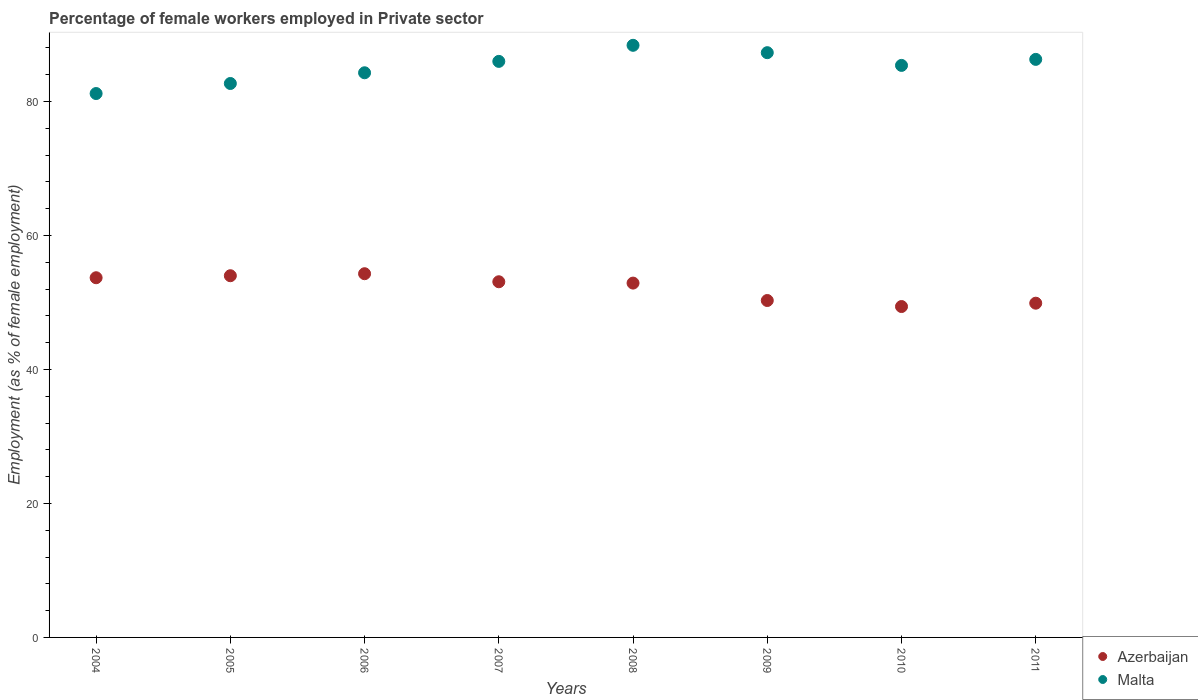How many different coloured dotlines are there?
Your answer should be compact. 2. Is the number of dotlines equal to the number of legend labels?
Give a very brief answer. Yes. What is the percentage of females employed in Private sector in Malta in 2010?
Your answer should be compact. 85.4. Across all years, what is the maximum percentage of females employed in Private sector in Malta?
Keep it short and to the point. 88.4. Across all years, what is the minimum percentage of females employed in Private sector in Malta?
Ensure brevity in your answer.  81.2. In which year was the percentage of females employed in Private sector in Azerbaijan minimum?
Your response must be concise. 2010. What is the total percentage of females employed in Private sector in Malta in the graph?
Make the answer very short. 681.6. What is the difference between the percentage of females employed in Private sector in Malta in 2005 and that in 2009?
Your answer should be very brief. -4.6. What is the difference between the percentage of females employed in Private sector in Malta in 2006 and the percentage of females employed in Private sector in Azerbaijan in 2011?
Your answer should be very brief. 34.4. What is the average percentage of females employed in Private sector in Malta per year?
Provide a succinct answer. 85.2. In the year 2008, what is the difference between the percentage of females employed in Private sector in Malta and percentage of females employed in Private sector in Azerbaijan?
Your response must be concise. 35.5. What is the ratio of the percentage of females employed in Private sector in Malta in 2009 to that in 2011?
Offer a terse response. 1.01. Is the percentage of females employed in Private sector in Malta in 2004 less than that in 2011?
Your response must be concise. Yes. Is the difference between the percentage of females employed in Private sector in Malta in 2004 and 2006 greater than the difference between the percentage of females employed in Private sector in Azerbaijan in 2004 and 2006?
Keep it short and to the point. No. What is the difference between the highest and the second highest percentage of females employed in Private sector in Malta?
Provide a short and direct response. 1.1. What is the difference between the highest and the lowest percentage of females employed in Private sector in Azerbaijan?
Make the answer very short. 4.9. In how many years, is the percentage of females employed in Private sector in Malta greater than the average percentage of females employed in Private sector in Malta taken over all years?
Provide a short and direct response. 5. Is the sum of the percentage of females employed in Private sector in Malta in 2007 and 2010 greater than the maximum percentage of females employed in Private sector in Azerbaijan across all years?
Ensure brevity in your answer.  Yes. Is the percentage of females employed in Private sector in Azerbaijan strictly greater than the percentage of females employed in Private sector in Malta over the years?
Keep it short and to the point. No. Is the percentage of females employed in Private sector in Azerbaijan strictly less than the percentage of females employed in Private sector in Malta over the years?
Provide a short and direct response. Yes. What is the difference between two consecutive major ticks on the Y-axis?
Provide a succinct answer. 20. Are the values on the major ticks of Y-axis written in scientific E-notation?
Offer a very short reply. No. Does the graph contain any zero values?
Offer a terse response. No. How many legend labels are there?
Offer a terse response. 2. What is the title of the graph?
Keep it short and to the point. Percentage of female workers employed in Private sector. Does "Somalia" appear as one of the legend labels in the graph?
Your answer should be very brief. No. What is the label or title of the X-axis?
Give a very brief answer. Years. What is the label or title of the Y-axis?
Offer a terse response. Employment (as % of female employment). What is the Employment (as % of female employment) in Azerbaijan in 2004?
Ensure brevity in your answer.  53.7. What is the Employment (as % of female employment) of Malta in 2004?
Offer a very short reply. 81.2. What is the Employment (as % of female employment) of Azerbaijan in 2005?
Ensure brevity in your answer.  54. What is the Employment (as % of female employment) in Malta in 2005?
Offer a very short reply. 82.7. What is the Employment (as % of female employment) of Azerbaijan in 2006?
Offer a very short reply. 54.3. What is the Employment (as % of female employment) in Malta in 2006?
Offer a terse response. 84.3. What is the Employment (as % of female employment) in Azerbaijan in 2007?
Offer a very short reply. 53.1. What is the Employment (as % of female employment) of Azerbaijan in 2008?
Ensure brevity in your answer.  52.9. What is the Employment (as % of female employment) in Malta in 2008?
Keep it short and to the point. 88.4. What is the Employment (as % of female employment) in Azerbaijan in 2009?
Provide a succinct answer. 50.3. What is the Employment (as % of female employment) in Malta in 2009?
Offer a very short reply. 87.3. What is the Employment (as % of female employment) of Azerbaijan in 2010?
Keep it short and to the point. 49.4. What is the Employment (as % of female employment) in Malta in 2010?
Offer a terse response. 85.4. What is the Employment (as % of female employment) in Azerbaijan in 2011?
Your response must be concise. 49.9. What is the Employment (as % of female employment) of Malta in 2011?
Offer a terse response. 86.3. Across all years, what is the maximum Employment (as % of female employment) of Azerbaijan?
Offer a terse response. 54.3. Across all years, what is the maximum Employment (as % of female employment) of Malta?
Your response must be concise. 88.4. Across all years, what is the minimum Employment (as % of female employment) in Azerbaijan?
Provide a succinct answer. 49.4. Across all years, what is the minimum Employment (as % of female employment) in Malta?
Provide a short and direct response. 81.2. What is the total Employment (as % of female employment) of Azerbaijan in the graph?
Your answer should be compact. 417.6. What is the total Employment (as % of female employment) of Malta in the graph?
Ensure brevity in your answer.  681.6. What is the difference between the Employment (as % of female employment) in Azerbaijan in 2004 and that in 2005?
Keep it short and to the point. -0.3. What is the difference between the Employment (as % of female employment) in Malta in 2004 and that in 2005?
Your answer should be compact. -1.5. What is the difference between the Employment (as % of female employment) of Azerbaijan in 2004 and that in 2006?
Keep it short and to the point. -0.6. What is the difference between the Employment (as % of female employment) of Malta in 2004 and that in 2006?
Your response must be concise. -3.1. What is the difference between the Employment (as % of female employment) in Azerbaijan in 2004 and that in 2008?
Your answer should be compact. 0.8. What is the difference between the Employment (as % of female employment) of Malta in 2004 and that in 2008?
Keep it short and to the point. -7.2. What is the difference between the Employment (as % of female employment) of Azerbaijan in 2004 and that in 2009?
Your answer should be very brief. 3.4. What is the difference between the Employment (as % of female employment) of Malta in 2004 and that in 2009?
Your answer should be compact. -6.1. What is the difference between the Employment (as % of female employment) in Malta in 2004 and that in 2010?
Your answer should be compact. -4.2. What is the difference between the Employment (as % of female employment) of Azerbaijan in 2004 and that in 2011?
Keep it short and to the point. 3.8. What is the difference between the Employment (as % of female employment) in Azerbaijan in 2005 and that in 2006?
Make the answer very short. -0.3. What is the difference between the Employment (as % of female employment) in Azerbaijan in 2005 and that in 2008?
Your answer should be very brief. 1.1. What is the difference between the Employment (as % of female employment) in Malta in 2005 and that in 2008?
Offer a very short reply. -5.7. What is the difference between the Employment (as % of female employment) in Azerbaijan in 2005 and that in 2009?
Provide a short and direct response. 3.7. What is the difference between the Employment (as % of female employment) in Malta in 2005 and that in 2009?
Your response must be concise. -4.6. What is the difference between the Employment (as % of female employment) in Azerbaijan in 2005 and that in 2010?
Provide a succinct answer. 4.6. What is the difference between the Employment (as % of female employment) of Malta in 2005 and that in 2010?
Make the answer very short. -2.7. What is the difference between the Employment (as % of female employment) in Azerbaijan in 2005 and that in 2011?
Keep it short and to the point. 4.1. What is the difference between the Employment (as % of female employment) of Azerbaijan in 2006 and that in 2007?
Keep it short and to the point. 1.2. What is the difference between the Employment (as % of female employment) in Azerbaijan in 2006 and that in 2008?
Offer a very short reply. 1.4. What is the difference between the Employment (as % of female employment) in Malta in 2006 and that in 2009?
Your answer should be compact. -3. What is the difference between the Employment (as % of female employment) in Malta in 2006 and that in 2010?
Provide a succinct answer. -1.1. What is the difference between the Employment (as % of female employment) in Malta in 2006 and that in 2011?
Offer a very short reply. -2. What is the difference between the Employment (as % of female employment) of Azerbaijan in 2007 and that in 2008?
Provide a succinct answer. 0.2. What is the difference between the Employment (as % of female employment) in Malta in 2007 and that in 2009?
Your answer should be very brief. -1.3. What is the difference between the Employment (as % of female employment) of Malta in 2007 and that in 2010?
Ensure brevity in your answer.  0.6. What is the difference between the Employment (as % of female employment) of Malta in 2007 and that in 2011?
Make the answer very short. -0.3. What is the difference between the Employment (as % of female employment) in Azerbaijan in 2008 and that in 2009?
Your answer should be compact. 2.6. What is the difference between the Employment (as % of female employment) in Malta in 2008 and that in 2009?
Provide a short and direct response. 1.1. What is the difference between the Employment (as % of female employment) in Azerbaijan in 2008 and that in 2011?
Your answer should be very brief. 3. What is the difference between the Employment (as % of female employment) in Azerbaijan in 2009 and that in 2010?
Provide a short and direct response. 0.9. What is the difference between the Employment (as % of female employment) in Azerbaijan in 2009 and that in 2011?
Offer a very short reply. 0.4. What is the difference between the Employment (as % of female employment) of Malta in 2009 and that in 2011?
Provide a succinct answer. 1. What is the difference between the Employment (as % of female employment) of Malta in 2010 and that in 2011?
Offer a very short reply. -0.9. What is the difference between the Employment (as % of female employment) of Azerbaijan in 2004 and the Employment (as % of female employment) of Malta in 2005?
Offer a terse response. -29. What is the difference between the Employment (as % of female employment) of Azerbaijan in 2004 and the Employment (as % of female employment) of Malta in 2006?
Make the answer very short. -30.6. What is the difference between the Employment (as % of female employment) of Azerbaijan in 2004 and the Employment (as % of female employment) of Malta in 2007?
Ensure brevity in your answer.  -32.3. What is the difference between the Employment (as % of female employment) in Azerbaijan in 2004 and the Employment (as % of female employment) in Malta in 2008?
Your answer should be very brief. -34.7. What is the difference between the Employment (as % of female employment) of Azerbaijan in 2004 and the Employment (as % of female employment) of Malta in 2009?
Provide a short and direct response. -33.6. What is the difference between the Employment (as % of female employment) of Azerbaijan in 2004 and the Employment (as % of female employment) of Malta in 2010?
Keep it short and to the point. -31.7. What is the difference between the Employment (as % of female employment) of Azerbaijan in 2004 and the Employment (as % of female employment) of Malta in 2011?
Your answer should be very brief. -32.6. What is the difference between the Employment (as % of female employment) in Azerbaijan in 2005 and the Employment (as % of female employment) in Malta in 2006?
Your response must be concise. -30.3. What is the difference between the Employment (as % of female employment) in Azerbaijan in 2005 and the Employment (as % of female employment) in Malta in 2007?
Offer a very short reply. -32. What is the difference between the Employment (as % of female employment) in Azerbaijan in 2005 and the Employment (as % of female employment) in Malta in 2008?
Keep it short and to the point. -34.4. What is the difference between the Employment (as % of female employment) in Azerbaijan in 2005 and the Employment (as % of female employment) in Malta in 2009?
Offer a terse response. -33.3. What is the difference between the Employment (as % of female employment) in Azerbaijan in 2005 and the Employment (as % of female employment) in Malta in 2010?
Give a very brief answer. -31.4. What is the difference between the Employment (as % of female employment) of Azerbaijan in 2005 and the Employment (as % of female employment) of Malta in 2011?
Provide a succinct answer. -32.3. What is the difference between the Employment (as % of female employment) in Azerbaijan in 2006 and the Employment (as % of female employment) in Malta in 2007?
Keep it short and to the point. -31.7. What is the difference between the Employment (as % of female employment) of Azerbaijan in 2006 and the Employment (as % of female employment) of Malta in 2008?
Your answer should be compact. -34.1. What is the difference between the Employment (as % of female employment) in Azerbaijan in 2006 and the Employment (as % of female employment) in Malta in 2009?
Give a very brief answer. -33. What is the difference between the Employment (as % of female employment) of Azerbaijan in 2006 and the Employment (as % of female employment) of Malta in 2010?
Ensure brevity in your answer.  -31.1. What is the difference between the Employment (as % of female employment) in Azerbaijan in 2006 and the Employment (as % of female employment) in Malta in 2011?
Provide a succinct answer. -32. What is the difference between the Employment (as % of female employment) of Azerbaijan in 2007 and the Employment (as % of female employment) of Malta in 2008?
Provide a short and direct response. -35.3. What is the difference between the Employment (as % of female employment) in Azerbaijan in 2007 and the Employment (as % of female employment) in Malta in 2009?
Your answer should be very brief. -34.2. What is the difference between the Employment (as % of female employment) in Azerbaijan in 2007 and the Employment (as % of female employment) in Malta in 2010?
Your answer should be compact. -32.3. What is the difference between the Employment (as % of female employment) in Azerbaijan in 2007 and the Employment (as % of female employment) in Malta in 2011?
Provide a succinct answer. -33.2. What is the difference between the Employment (as % of female employment) of Azerbaijan in 2008 and the Employment (as % of female employment) of Malta in 2009?
Ensure brevity in your answer.  -34.4. What is the difference between the Employment (as % of female employment) of Azerbaijan in 2008 and the Employment (as % of female employment) of Malta in 2010?
Your response must be concise. -32.5. What is the difference between the Employment (as % of female employment) in Azerbaijan in 2008 and the Employment (as % of female employment) in Malta in 2011?
Your answer should be compact. -33.4. What is the difference between the Employment (as % of female employment) in Azerbaijan in 2009 and the Employment (as % of female employment) in Malta in 2010?
Your answer should be very brief. -35.1. What is the difference between the Employment (as % of female employment) of Azerbaijan in 2009 and the Employment (as % of female employment) of Malta in 2011?
Keep it short and to the point. -36. What is the difference between the Employment (as % of female employment) in Azerbaijan in 2010 and the Employment (as % of female employment) in Malta in 2011?
Keep it short and to the point. -36.9. What is the average Employment (as % of female employment) in Azerbaijan per year?
Offer a terse response. 52.2. What is the average Employment (as % of female employment) in Malta per year?
Make the answer very short. 85.2. In the year 2004, what is the difference between the Employment (as % of female employment) in Azerbaijan and Employment (as % of female employment) in Malta?
Your response must be concise. -27.5. In the year 2005, what is the difference between the Employment (as % of female employment) of Azerbaijan and Employment (as % of female employment) of Malta?
Offer a terse response. -28.7. In the year 2007, what is the difference between the Employment (as % of female employment) of Azerbaijan and Employment (as % of female employment) of Malta?
Your answer should be very brief. -32.9. In the year 2008, what is the difference between the Employment (as % of female employment) of Azerbaijan and Employment (as % of female employment) of Malta?
Provide a succinct answer. -35.5. In the year 2009, what is the difference between the Employment (as % of female employment) of Azerbaijan and Employment (as % of female employment) of Malta?
Keep it short and to the point. -37. In the year 2010, what is the difference between the Employment (as % of female employment) of Azerbaijan and Employment (as % of female employment) of Malta?
Ensure brevity in your answer.  -36. In the year 2011, what is the difference between the Employment (as % of female employment) in Azerbaijan and Employment (as % of female employment) in Malta?
Ensure brevity in your answer.  -36.4. What is the ratio of the Employment (as % of female employment) in Malta in 2004 to that in 2005?
Your answer should be compact. 0.98. What is the ratio of the Employment (as % of female employment) in Malta in 2004 to that in 2006?
Make the answer very short. 0.96. What is the ratio of the Employment (as % of female employment) of Azerbaijan in 2004 to that in 2007?
Offer a terse response. 1.01. What is the ratio of the Employment (as % of female employment) of Malta in 2004 to that in 2007?
Provide a succinct answer. 0.94. What is the ratio of the Employment (as % of female employment) in Azerbaijan in 2004 to that in 2008?
Give a very brief answer. 1.02. What is the ratio of the Employment (as % of female employment) in Malta in 2004 to that in 2008?
Your answer should be compact. 0.92. What is the ratio of the Employment (as % of female employment) of Azerbaijan in 2004 to that in 2009?
Provide a succinct answer. 1.07. What is the ratio of the Employment (as % of female employment) in Malta in 2004 to that in 2009?
Offer a terse response. 0.93. What is the ratio of the Employment (as % of female employment) in Azerbaijan in 2004 to that in 2010?
Make the answer very short. 1.09. What is the ratio of the Employment (as % of female employment) in Malta in 2004 to that in 2010?
Offer a terse response. 0.95. What is the ratio of the Employment (as % of female employment) of Azerbaijan in 2004 to that in 2011?
Ensure brevity in your answer.  1.08. What is the ratio of the Employment (as % of female employment) in Malta in 2004 to that in 2011?
Provide a short and direct response. 0.94. What is the ratio of the Employment (as % of female employment) of Azerbaijan in 2005 to that in 2006?
Your answer should be very brief. 0.99. What is the ratio of the Employment (as % of female employment) of Malta in 2005 to that in 2006?
Your answer should be very brief. 0.98. What is the ratio of the Employment (as % of female employment) of Azerbaijan in 2005 to that in 2007?
Provide a short and direct response. 1.02. What is the ratio of the Employment (as % of female employment) in Malta in 2005 to that in 2007?
Provide a succinct answer. 0.96. What is the ratio of the Employment (as % of female employment) of Azerbaijan in 2005 to that in 2008?
Offer a very short reply. 1.02. What is the ratio of the Employment (as % of female employment) of Malta in 2005 to that in 2008?
Your answer should be very brief. 0.94. What is the ratio of the Employment (as % of female employment) in Azerbaijan in 2005 to that in 2009?
Provide a short and direct response. 1.07. What is the ratio of the Employment (as % of female employment) of Malta in 2005 to that in 2009?
Provide a short and direct response. 0.95. What is the ratio of the Employment (as % of female employment) of Azerbaijan in 2005 to that in 2010?
Offer a terse response. 1.09. What is the ratio of the Employment (as % of female employment) of Malta in 2005 to that in 2010?
Your answer should be compact. 0.97. What is the ratio of the Employment (as % of female employment) in Azerbaijan in 2005 to that in 2011?
Your response must be concise. 1.08. What is the ratio of the Employment (as % of female employment) of Malta in 2005 to that in 2011?
Your response must be concise. 0.96. What is the ratio of the Employment (as % of female employment) of Azerbaijan in 2006 to that in 2007?
Ensure brevity in your answer.  1.02. What is the ratio of the Employment (as % of female employment) in Malta in 2006 to that in 2007?
Provide a short and direct response. 0.98. What is the ratio of the Employment (as % of female employment) in Azerbaijan in 2006 to that in 2008?
Your response must be concise. 1.03. What is the ratio of the Employment (as % of female employment) in Malta in 2006 to that in 2008?
Your answer should be compact. 0.95. What is the ratio of the Employment (as % of female employment) in Azerbaijan in 2006 to that in 2009?
Provide a short and direct response. 1.08. What is the ratio of the Employment (as % of female employment) in Malta in 2006 to that in 2009?
Keep it short and to the point. 0.97. What is the ratio of the Employment (as % of female employment) in Azerbaijan in 2006 to that in 2010?
Provide a succinct answer. 1.1. What is the ratio of the Employment (as % of female employment) in Malta in 2006 to that in 2010?
Keep it short and to the point. 0.99. What is the ratio of the Employment (as % of female employment) of Azerbaijan in 2006 to that in 2011?
Your answer should be very brief. 1.09. What is the ratio of the Employment (as % of female employment) in Malta in 2006 to that in 2011?
Provide a short and direct response. 0.98. What is the ratio of the Employment (as % of female employment) of Malta in 2007 to that in 2008?
Your answer should be compact. 0.97. What is the ratio of the Employment (as % of female employment) of Azerbaijan in 2007 to that in 2009?
Provide a short and direct response. 1.06. What is the ratio of the Employment (as % of female employment) of Malta in 2007 to that in 2009?
Give a very brief answer. 0.99. What is the ratio of the Employment (as % of female employment) of Azerbaijan in 2007 to that in 2010?
Your answer should be very brief. 1.07. What is the ratio of the Employment (as % of female employment) of Azerbaijan in 2007 to that in 2011?
Keep it short and to the point. 1.06. What is the ratio of the Employment (as % of female employment) in Malta in 2007 to that in 2011?
Give a very brief answer. 1. What is the ratio of the Employment (as % of female employment) in Azerbaijan in 2008 to that in 2009?
Your answer should be very brief. 1.05. What is the ratio of the Employment (as % of female employment) of Malta in 2008 to that in 2009?
Provide a short and direct response. 1.01. What is the ratio of the Employment (as % of female employment) in Azerbaijan in 2008 to that in 2010?
Offer a terse response. 1.07. What is the ratio of the Employment (as % of female employment) in Malta in 2008 to that in 2010?
Offer a terse response. 1.04. What is the ratio of the Employment (as % of female employment) in Azerbaijan in 2008 to that in 2011?
Offer a very short reply. 1.06. What is the ratio of the Employment (as % of female employment) in Malta in 2008 to that in 2011?
Keep it short and to the point. 1.02. What is the ratio of the Employment (as % of female employment) of Azerbaijan in 2009 to that in 2010?
Ensure brevity in your answer.  1.02. What is the ratio of the Employment (as % of female employment) of Malta in 2009 to that in 2010?
Your response must be concise. 1.02. What is the ratio of the Employment (as % of female employment) in Malta in 2009 to that in 2011?
Ensure brevity in your answer.  1.01. What is the ratio of the Employment (as % of female employment) in Azerbaijan in 2010 to that in 2011?
Provide a succinct answer. 0.99. What is the difference between the highest and the lowest Employment (as % of female employment) of Azerbaijan?
Your answer should be compact. 4.9. 